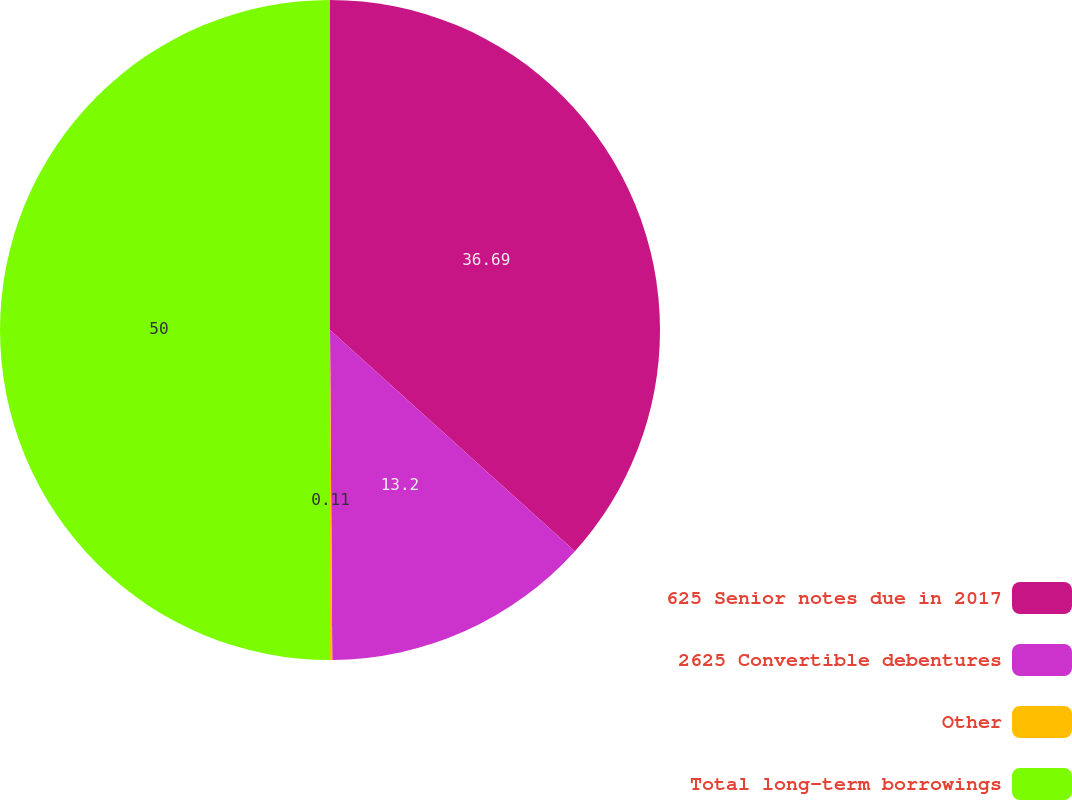Convert chart to OTSL. <chart><loc_0><loc_0><loc_500><loc_500><pie_chart><fcel>625 Senior notes due in 2017<fcel>2625 Convertible debentures<fcel>Other<fcel>Total long-term borrowings<nl><fcel>36.69%<fcel>13.2%<fcel>0.11%<fcel>50.0%<nl></chart> 